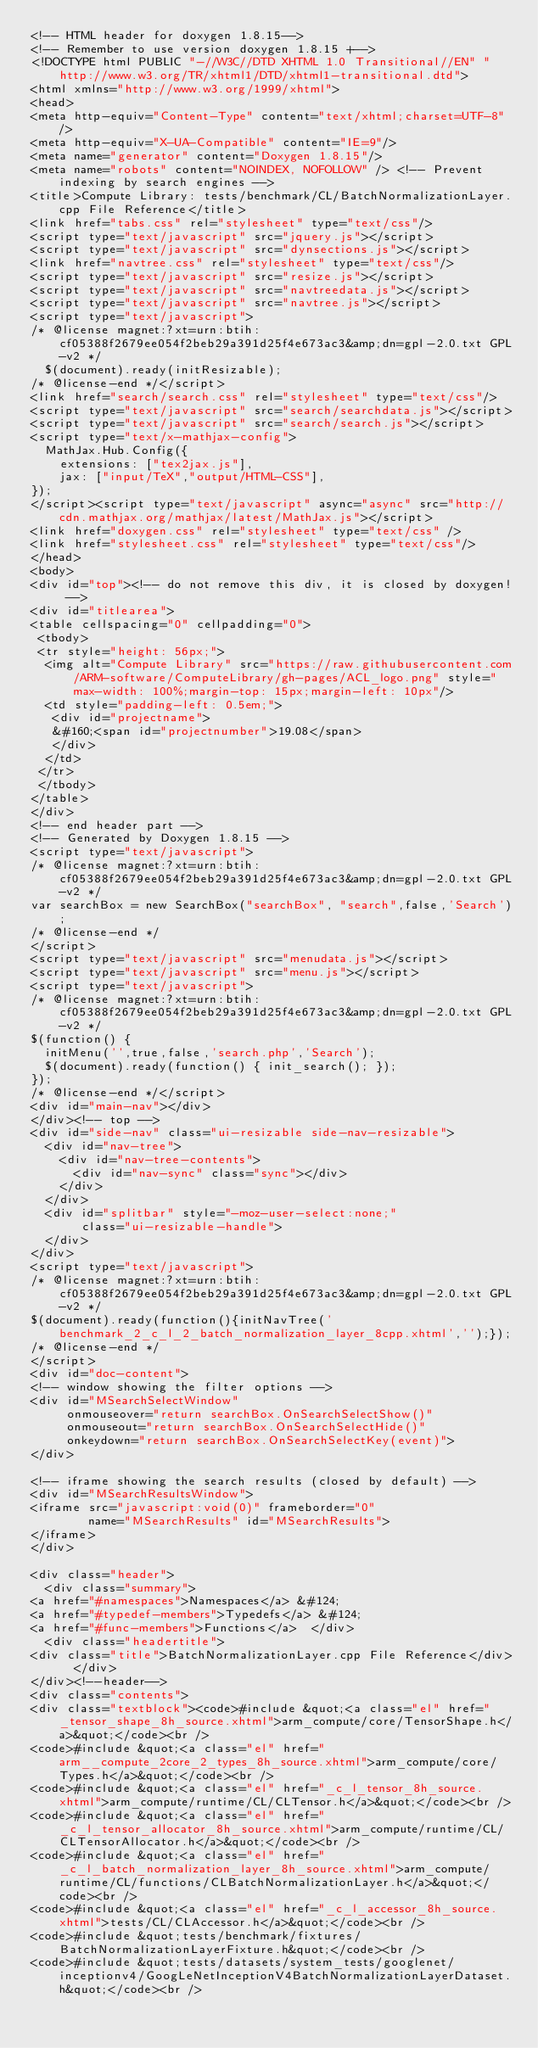Convert code to text. <code><loc_0><loc_0><loc_500><loc_500><_HTML_><!-- HTML header for doxygen 1.8.15-->
<!-- Remember to use version doxygen 1.8.15 +-->
<!DOCTYPE html PUBLIC "-//W3C//DTD XHTML 1.0 Transitional//EN" "http://www.w3.org/TR/xhtml1/DTD/xhtml1-transitional.dtd">
<html xmlns="http://www.w3.org/1999/xhtml">
<head>
<meta http-equiv="Content-Type" content="text/xhtml;charset=UTF-8"/>
<meta http-equiv="X-UA-Compatible" content="IE=9"/>
<meta name="generator" content="Doxygen 1.8.15"/>
<meta name="robots" content="NOINDEX, NOFOLLOW" /> <!-- Prevent indexing by search engines -->
<title>Compute Library: tests/benchmark/CL/BatchNormalizationLayer.cpp File Reference</title>
<link href="tabs.css" rel="stylesheet" type="text/css"/>
<script type="text/javascript" src="jquery.js"></script>
<script type="text/javascript" src="dynsections.js"></script>
<link href="navtree.css" rel="stylesheet" type="text/css"/>
<script type="text/javascript" src="resize.js"></script>
<script type="text/javascript" src="navtreedata.js"></script>
<script type="text/javascript" src="navtree.js"></script>
<script type="text/javascript">
/* @license magnet:?xt=urn:btih:cf05388f2679ee054f2beb29a391d25f4e673ac3&amp;dn=gpl-2.0.txt GPL-v2 */
  $(document).ready(initResizable);
/* @license-end */</script>
<link href="search/search.css" rel="stylesheet" type="text/css"/>
<script type="text/javascript" src="search/searchdata.js"></script>
<script type="text/javascript" src="search/search.js"></script>
<script type="text/x-mathjax-config">
  MathJax.Hub.Config({
    extensions: ["tex2jax.js"],
    jax: ["input/TeX","output/HTML-CSS"],
});
</script><script type="text/javascript" async="async" src="http://cdn.mathjax.org/mathjax/latest/MathJax.js"></script>
<link href="doxygen.css" rel="stylesheet" type="text/css" />
<link href="stylesheet.css" rel="stylesheet" type="text/css"/>
</head>
<body>
<div id="top"><!-- do not remove this div, it is closed by doxygen! -->
<div id="titlearea">
<table cellspacing="0" cellpadding="0">
 <tbody>
 <tr style="height: 56px;">
  <img alt="Compute Library" src="https://raw.githubusercontent.com/ARM-software/ComputeLibrary/gh-pages/ACL_logo.png" style="max-width: 100%;margin-top: 15px;margin-left: 10px"/>
  <td style="padding-left: 0.5em;">
   <div id="projectname">
   &#160;<span id="projectnumber">19.08</span>
   </div>
  </td>
 </tr>
 </tbody>
</table>
</div>
<!-- end header part -->
<!-- Generated by Doxygen 1.8.15 -->
<script type="text/javascript">
/* @license magnet:?xt=urn:btih:cf05388f2679ee054f2beb29a391d25f4e673ac3&amp;dn=gpl-2.0.txt GPL-v2 */
var searchBox = new SearchBox("searchBox", "search",false,'Search');
/* @license-end */
</script>
<script type="text/javascript" src="menudata.js"></script>
<script type="text/javascript" src="menu.js"></script>
<script type="text/javascript">
/* @license magnet:?xt=urn:btih:cf05388f2679ee054f2beb29a391d25f4e673ac3&amp;dn=gpl-2.0.txt GPL-v2 */
$(function() {
  initMenu('',true,false,'search.php','Search');
  $(document).ready(function() { init_search(); });
});
/* @license-end */</script>
<div id="main-nav"></div>
</div><!-- top -->
<div id="side-nav" class="ui-resizable side-nav-resizable">
  <div id="nav-tree">
    <div id="nav-tree-contents">
      <div id="nav-sync" class="sync"></div>
    </div>
  </div>
  <div id="splitbar" style="-moz-user-select:none;" 
       class="ui-resizable-handle">
  </div>
</div>
<script type="text/javascript">
/* @license magnet:?xt=urn:btih:cf05388f2679ee054f2beb29a391d25f4e673ac3&amp;dn=gpl-2.0.txt GPL-v2 */
$(document).ready(function(){initNavTree('benchmark_2_c_l_2_batch_normalization_layer_8cpp.xhtml','');});
/* @license-end */
</script>
<div id="doc-content">
<!-- window showing the filter options -->
<div id="MSearchSelectWindow"
     onmouseover="return searchBox.OnSearchSelectShow()"
     onmouseout="return searchBox.OnSearchSelectHide()"
     onkeydown="return searchBox.OnSearchSelectKey(event)">
</div>

<!-- iframe showing the search results (closed by default) -->
<div id="MSearchResultsWindow">
<iframe src="javascript:void(0)" frameborder="0" 
        name="MSearchResults" id="MSearchResults">
</iframe>
</div>

<div class="header">
  <div class="summary">
<a href="#namespaces">Namespaces</a> &#124;
<a href="#typedef-members">Typedefs</a> &#124;
<a href="#func-members">Functions</a>  </div>
  <div class="headertitle">
<div class="title">BatchNormalizationLayer.cpp File Reference</div>  </div>
</div><!--header-->
<div class="contents">
<div class="textblock"><code>#include &quot;<a class="el" href="_tensor_shape_8h_source.xhtml">arm_compute/core/TensorShape.h</a>&quot;</code><br />
<code>#include &quot;<a class="el" href="arm__compute_2core_2_types_8h_source.xhtml">arm_compute/core/Types.h</a>&quot;</code><br />
<code>#include &quot;<a class="el" href="_c_l_tensor_8h_source.xhtml">arm_compute/runtime/CL/CLTensor.h</a>&quot;</code><br />
<code>#include &quot;<a class="el" href="_c_l_tensor_allocator_8h_source.xhtml">arm_compute/runtime/CL/CLTensorAllocator.h</a>&quot;</code><br />
<code>#include &quot;<a class="el" href="_c_l_batch_normalization_layer_8h_source.xhtml">arm_compute/runtime/CL/functions/CLBatchNormalizationLayer.h</a>&quot;</code><br />
<code>#include &quot;<a class="el" href="_c_l_accessor_8h_source.xhtml">tests/CL/CLAccessor.h</a>&quot;</code><br />
<code>#include &quot;tests/benchmark/fixtures/BatchNormalizationLayerFixture.h&quot;</code><br />
<code>#include &quot;tests/datasets/system_tests/googlenet/inceptionv4/GoogLeNetInceptionV4BatchNormalizationLayerDataset.h&quot;</code><br /></code> 